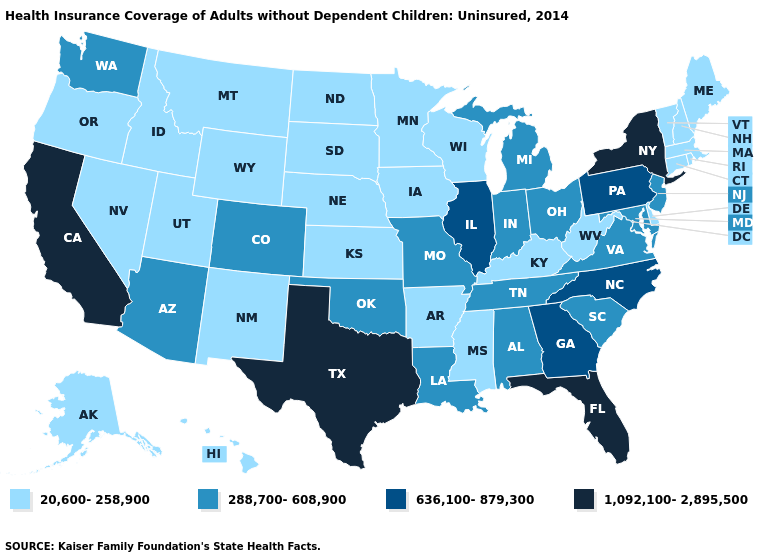Name the states that have a value in the range 20,600-258,900?
Concise answer only. Alaska, Arkansas, Connecticut, Delaware, Hawaii, Idaho, Iowa, Kansas, Kentucky, Maine, Massachusetts, Minnesota, Mississippi, Montana, Nebraska, Nevada, New Hampshire, New Mexico, North Dakota, Oregon, Rhode Island, South Dakota, Utah, Vermont, West Virginia, Wisconsin, Wyoming. What is the lowest value in states that border Idaho?
Be succinct. 20,600-258,900. Does Arizona have a lower value than Mississippi?
Be succinct. No. Among the states that border Minnesota , which have the highest value?
Concise answer only. Iowa, North Dakota, South Dakota, Wisconsin. Does Alabama have a higher value than Wisconsin?
Be succinct. Yes. How many symbols are there in the legend?
Be succinct. 4. Does Montana have the lowest value in the USA?
Be succinct. Yes. What is the value of Colorado?
Short answer required. 288,700-608,900. What is the lowest value in the USA?
Answer briefly. 20,600-258,900. Name the states that have a value in the range 288,700-608,900?
Be succinct. Alabama, Arizona, Colorado, Indiana, Louisiana, Maryland, Michigan, Missouri, New Jersey, Ohio, Oklahoma, South Carolina, Tennessee, Virginia, Washington. Does Pennsylvania have a higher value than Missouri?
Concise answer only. Yes. Which states have the highest value in the USA?
Answer briefly. California, Florida, New York, Texas. What is the value of Colorado?
Quick response, please. 288,700-608,900. 